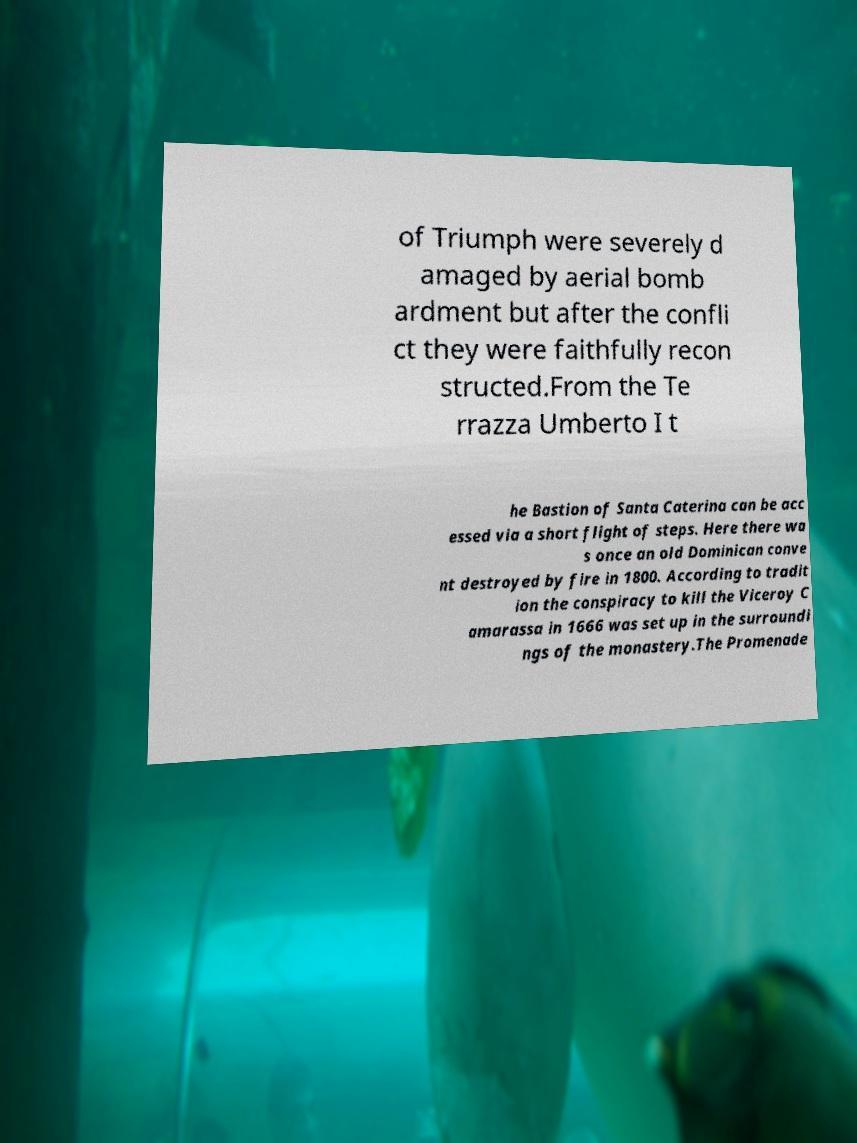Can you accurately transcribe the text from the provided image for me? of Triumph were severely d amaged by aerial bomb ardment but after the confli ct they were faithfully recon structed.From the Te rrazza Umberto I t he Bastion of Santa Caterina can be acc essed via a short flight of steps. Here there wa s once an old Dominican conve nt destroyed by fire in 1800. According to tradit ion the conspiracy to kill the Viceroy C amarassa in 1666 was set up in the surroundi ngs of the monastery.The Promenade 